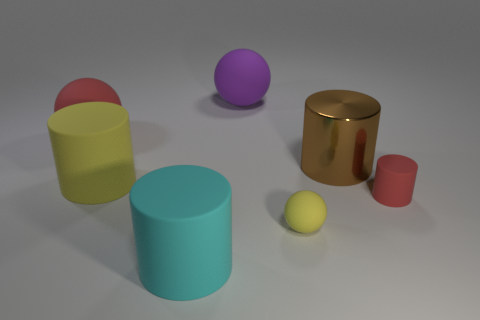There is a rubber object that is the same color as the tiny matte cylinder; what size is it?
Give a very brief answer. Large. There is a red object that is the same shape as the tiny yellow rubber object; what material is it?
Offer a terse response. Rubber. What is the color of the object that is both behind the tiny red matte cylinder and on the right side of the purple sphere?
Make the answer very short. Brown. Are there fewer purple objects than objects?
Provide a succinct answer. Yes. There is a small rubber cylinder; does it have the same color as the large sphere to the left of the yellow cylinder?
Provide a succinct answer. Yes. Is the number of big matte balls in front of the big cyan object the same as the number of rubber spheres in front of the red rubber sphere?
Give a very brief answer. No. How many small objects have the same shape as the big brown metal object?
Your answer should be compact. 1. Is there a big yellow cylinder?
Give a very brief answer. Yes. Is the large yellow thing made of the same material as the sphere in front of the small cylinder?
Provide a succinct answer. Yes. There is a purple object that is the same size as the cyan rubber thing; what is its material?
Ensure brevity in your answer.  Rubber. 